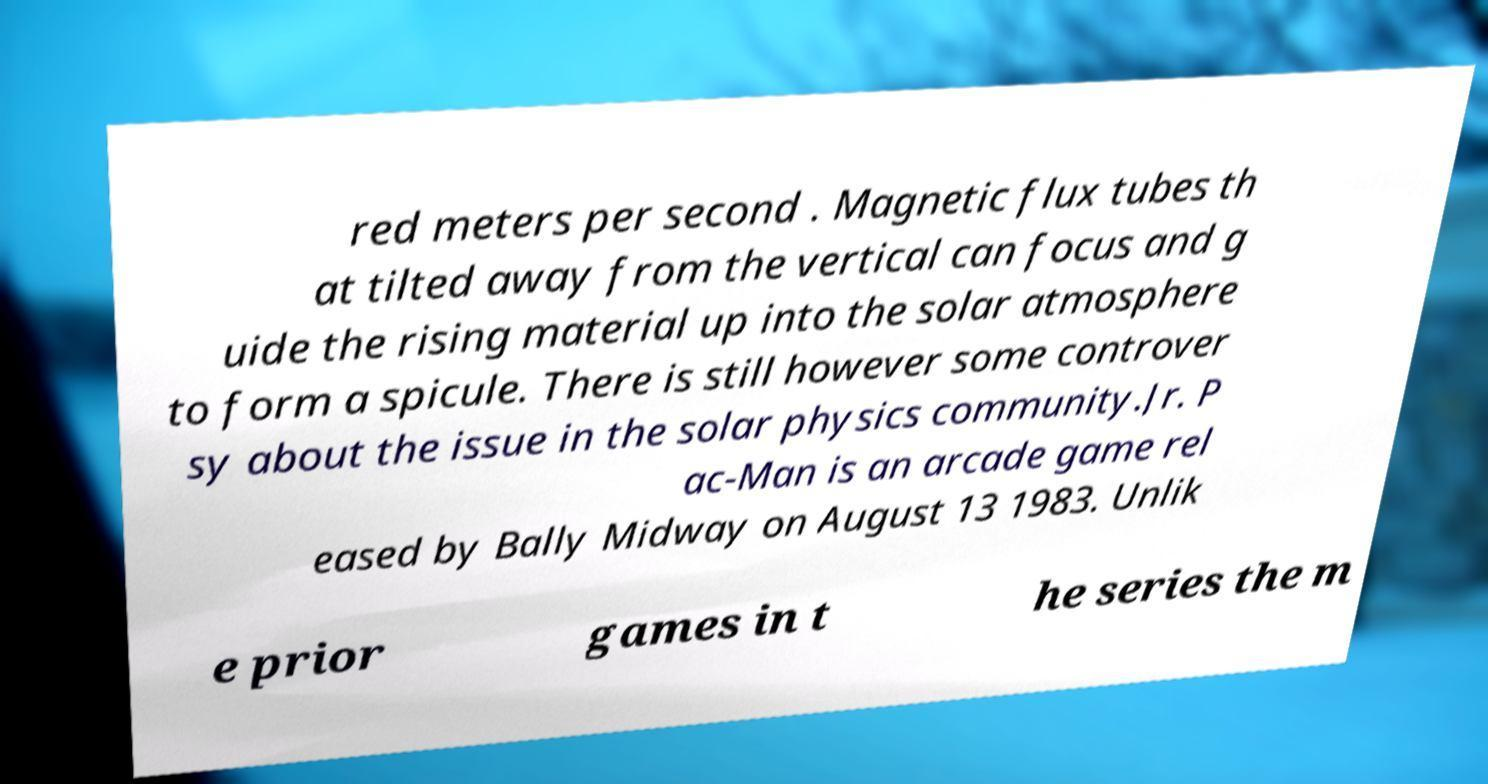What messages or text are displayed in this image? I need them in a readable, typed format. red meters per second . Magnetic flux tubes th at tilted away from the vertical can focus and g uide the rising material up into the solar atmosphere to form a spicule. There is still however some controver sy about the issue in the solar physics community.Jr. P ac-Man is an arcade game rel eased by Bally Midway on August 13 1983. Unlik e prior games in t he series the m 